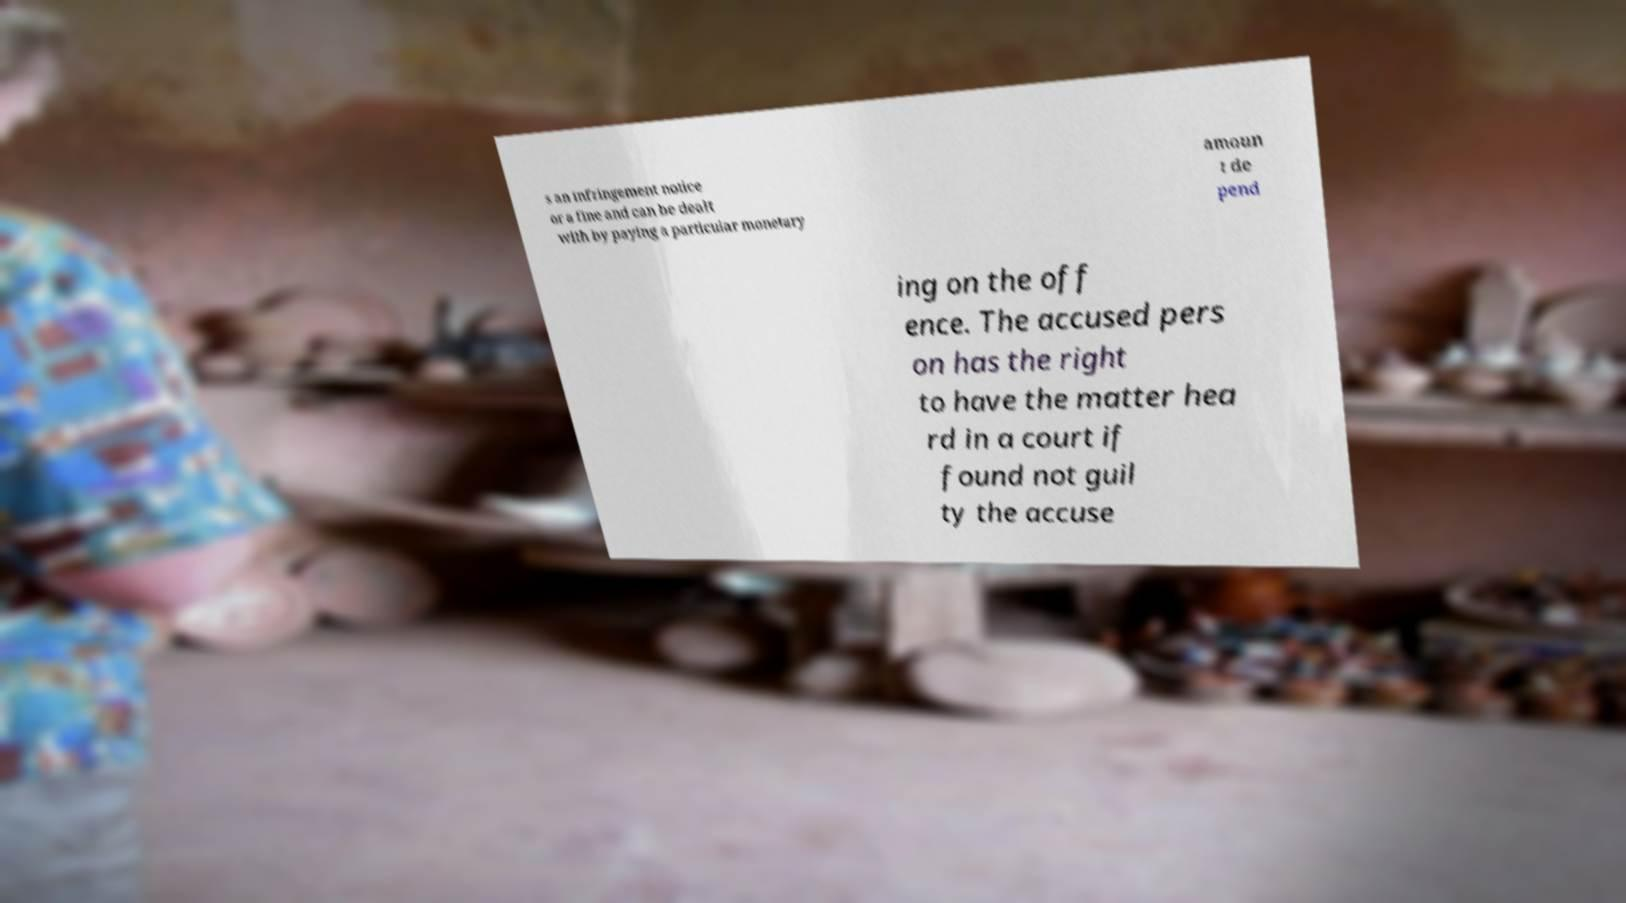Could you extract and type out the text from this image? s an infringement notice or a fine and can be dealt with by paying a particular monetary amoun t de pend ing on the off ence. The accused pers on has the right to have the matter hea rd in a court if found not guil ty the accuse 